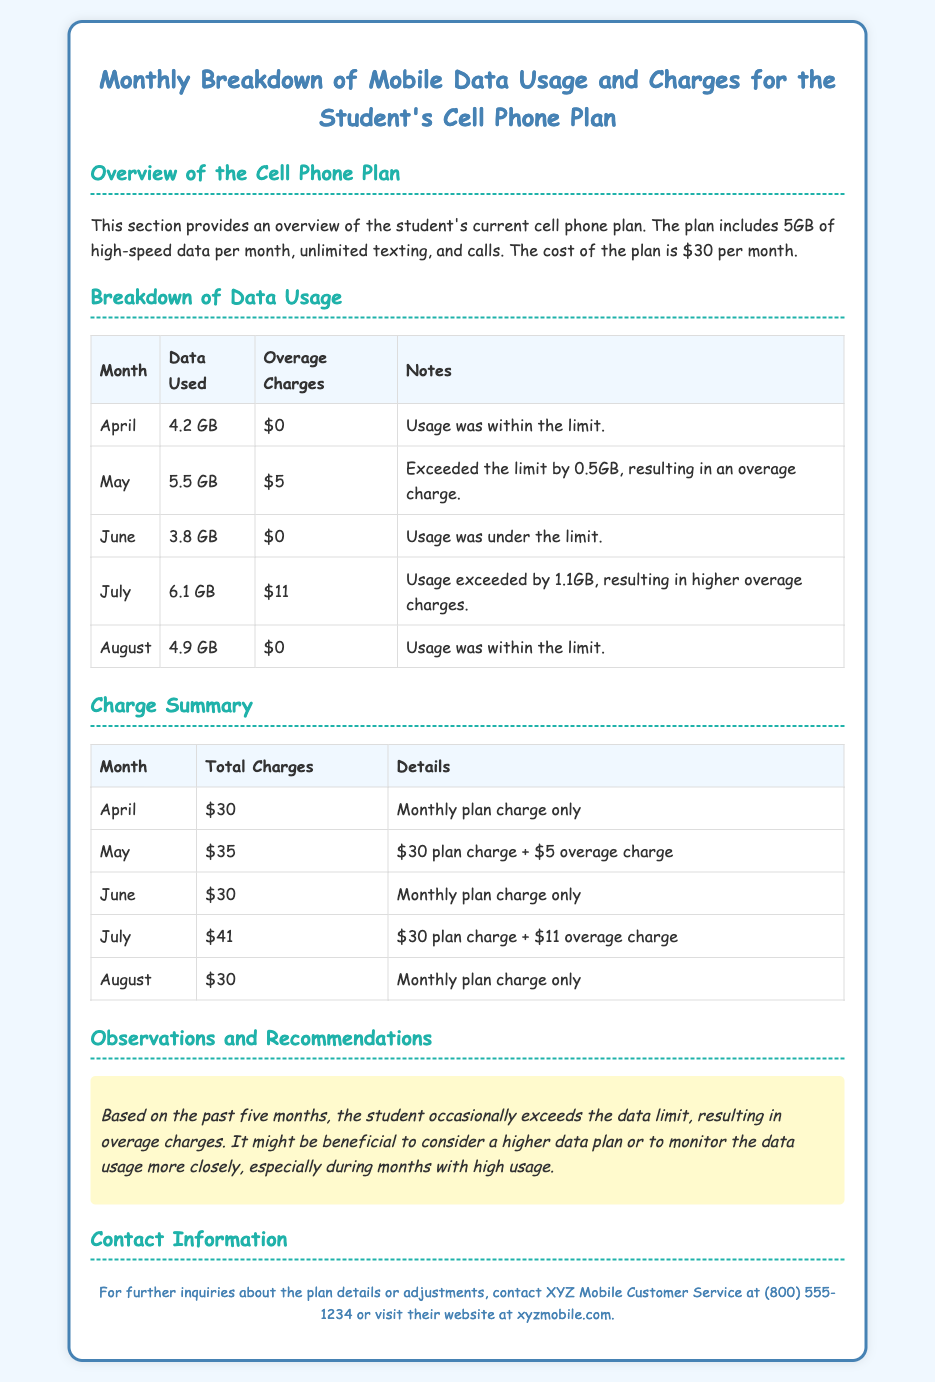What is the monthly cost of the student's cell phone plan? The monthly cost is mentioned in the overview of the cell phone plan, which is $30.
Answer: $30 How much data was used in July? The data usage for July is indicated in the breakdown of data usage table, which states 6.1 GB.
Answer: 6.1 GB What was the overage charge for May? The overage charge for May is given in the breakdown of data usage table, which shows $5.
Answer: $5 What was the total charge for July? The total charge for July is listed in the charge summary table, which shows $41.
Answer: $41 How many months exceeded the data limit? The table shows that May and July exceeded the data limit, which amounts to 2 months.
Answer: 2 months What recommendations are given in the observations section? The recommendation suggests considering a higher data plan or monitoring data usage more closely.
Answer: Higher data plan or monitor usage What is the data limit of the student’s cell phone plan? The data limit is mentioned in the overview section as 5GB per month.
Answer: 5GB Who should be contacted for further inquiries? The contact information section provides XYZ Mobile Customer Service as the point of inquiry.
Answer: XYZ Mobile Customer Service 